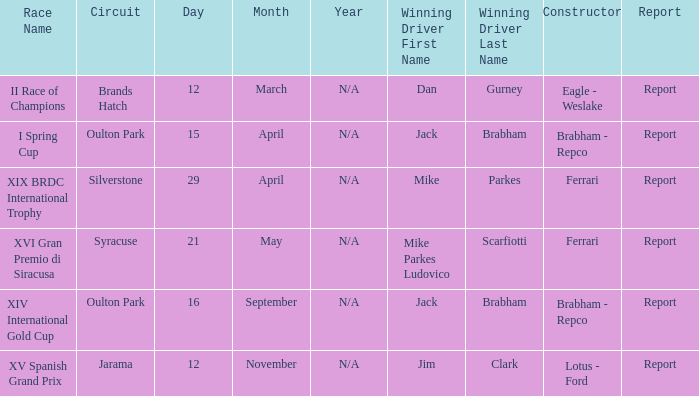What date was the xiv international gold cup? 16 September. 